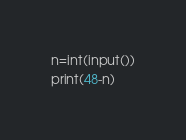Convert code to text. <code><loc_0><loc_0><loc_500><loc_500><_Python_>n=int(input())
print(48-n)</code> 